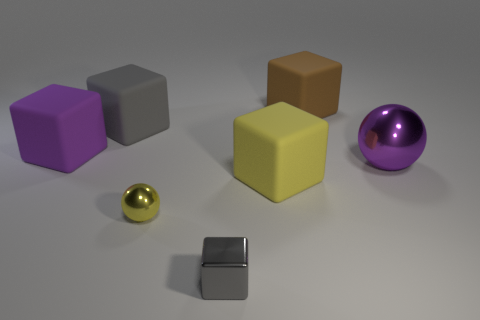Is the number of yellow metallic balls behind the large yellow matte thing the same as the number of big yellow matte cubes? The number of yellow metallic balls is not the same as the number of big yellow matte cubes. Behind the large yellow matte cube, there appears to be only one small yellow metallic ball, while there's one large yellow matte cube in front. 